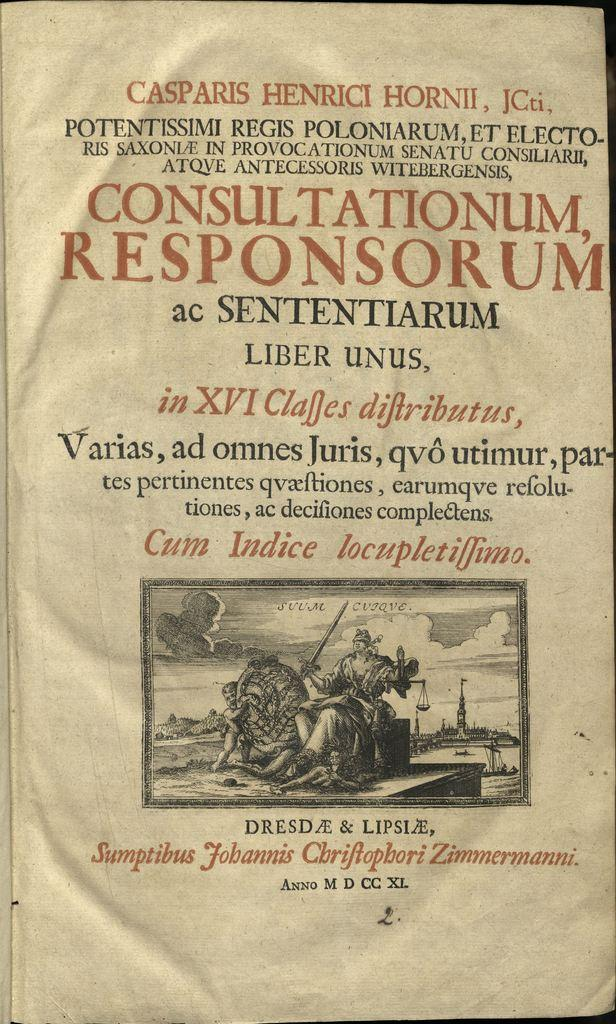<image>
Offer a succinct explanation of the picture presented. The paper is written in a foreign language and refers to Consultationum Responsorum. 